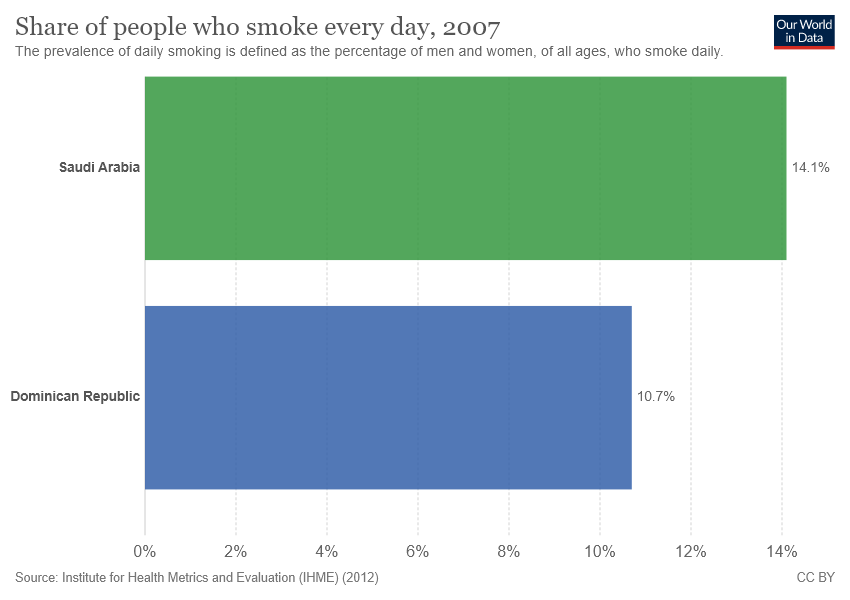Indicate a few pertinent items in this graphic. The percentage of people who smoke in Saudi Arabia is different from that of the Dominican Republic, with the former having a lower rate of 0.034%. The country represented by the green color bar is Saudi Arabia. 